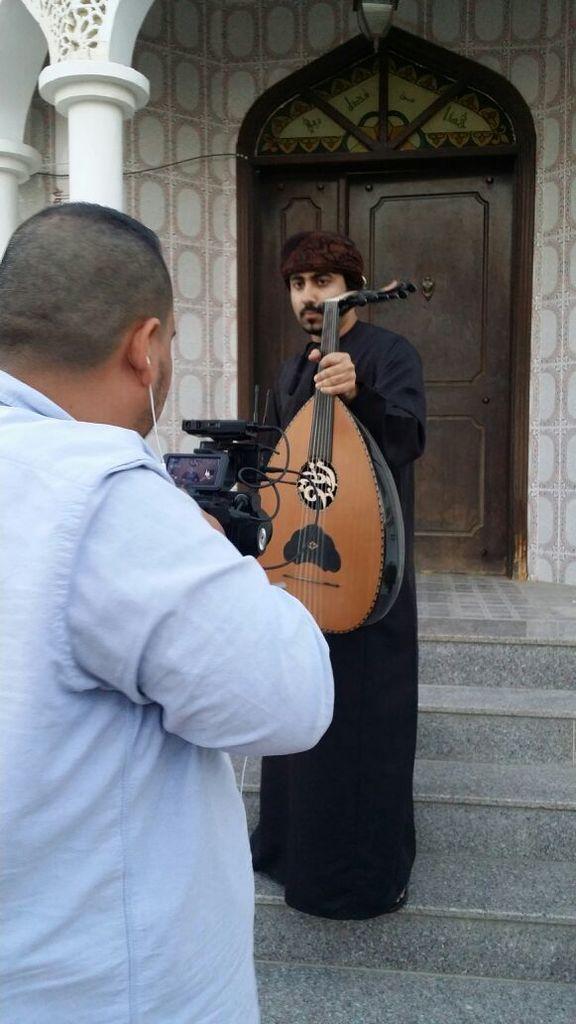Please provide a concise description of this image. On the background we can see a wall, door and a pillar. Here we can see a man wearing a black colour dress and holding a musical instrument in his hand. In Front of the picture we can see an other man holding a camera in his hand and recording. These are stairs. 